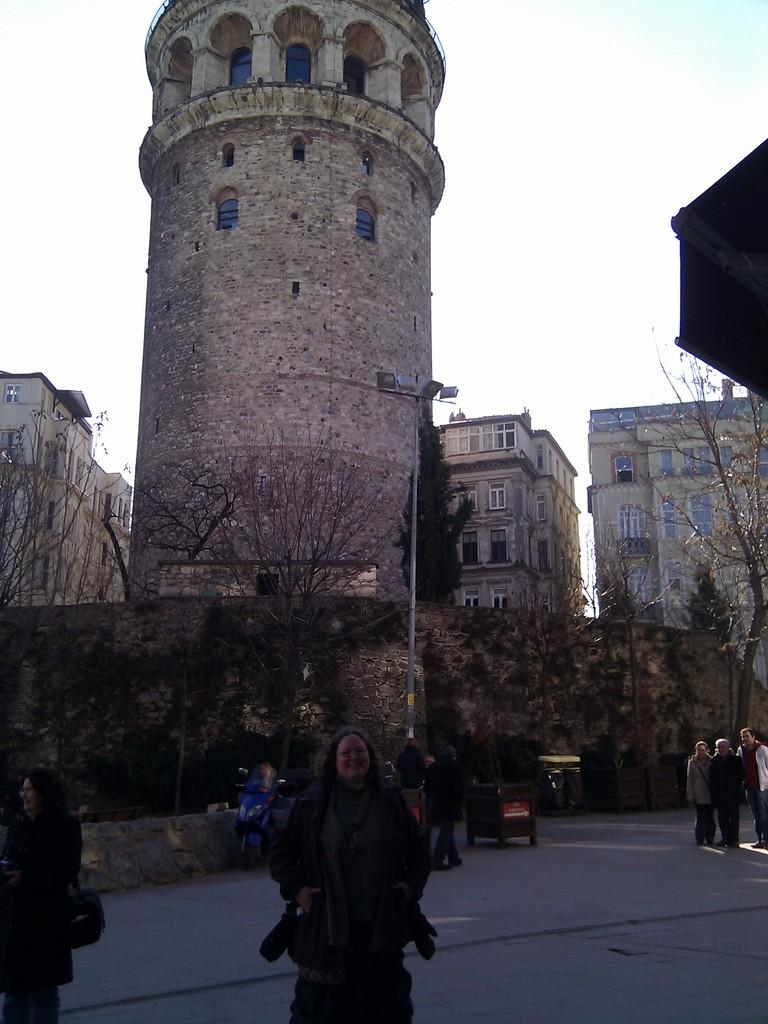What can be seen in the image that people might walk on? There is a path in the image that people might walk on. Who or what is present on the path? There are people on the path. What can be seen in the background of the image? There are trees, a light pole, buildings, a tower, and the sky visible in the background of the image. What type of powder is being used by the people on the path? There is no powder visible in the image, and the people on the path are not using any powder. 